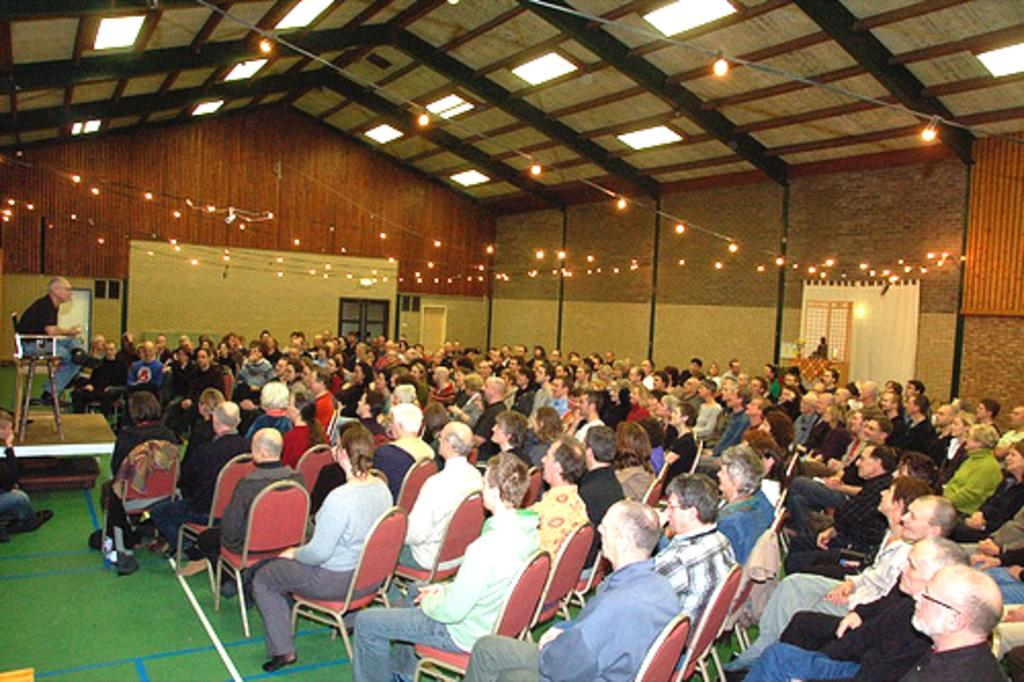What are the people in the image doing? The people in the image are seated. What are the people seated on? The people are seated on chairs. Can you describe the position of the man in the image? There is a man seated on a dais. What can be seen illuminating the scene in the image? Lights are visible in the image. What color is the carpet on the floor? The carpet on the floor is green. What type of nail is being hammered into the wall in the image? There is no nail being hammered into the wall in the image. How does the train pass through the room in the image? There is no train present in the image. 